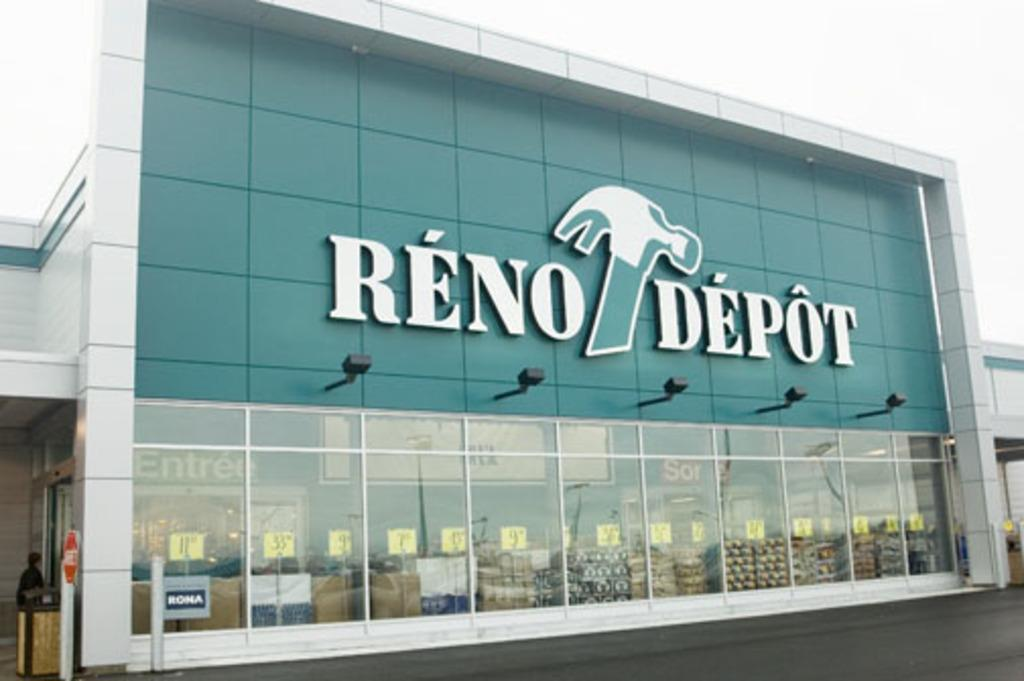What type of structure is present in the image? There is a building in the image. What colors are used to paint the building? The building is colored white and green. Are there any additional features on the building? Yes, there are lights on the building. What can be seen in the top right of the image? The sky is visible in the top right of the image. Reasoning: To create the conversation, we first identify the main subject of the image, which is the building. We then describe its colors and any additional features, such as the lights. Finally, we mention the sky visible in the top right of the image. Each question is designed to elicit a specific detail about the image that is known from the provided facts. Absurd Question/Answer: What type of loaf is being baked in the building's oven in the image? There is no indication of an oven or loaf in the image; it only features a building with lights and a visible sky. 